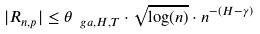<formula> <loc_0><loc_0><loc_500><loc_500>| R _ { n , p } | \leq \theta _ { \ g a , H , T } \cdot \sqrt { \log ( n ) } \cdot n ^ { - ( H - \gamma ) }</formula> 